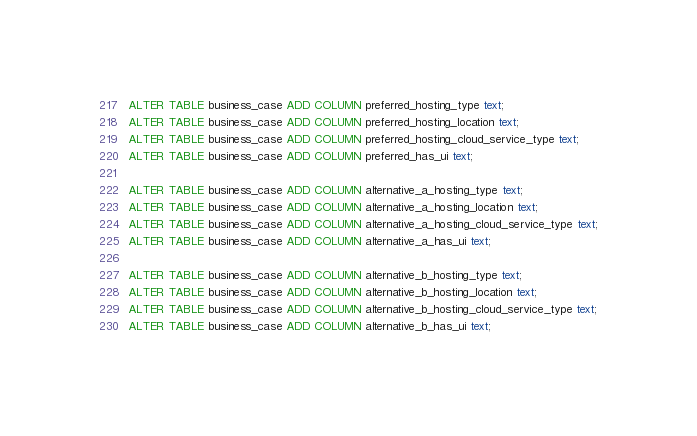Convert code to text. <code><loc_0><loc_0><loc_500><loc_500><_SQL_>ALTER TABLE business_case ADD COLUMN preferred_hosting_type text;
ALTER TABLE business_case ADD COLUMN preferred_hosting_location text;
ALTER TABLE business_case ADD COLUMN preferred_hosting_cloud_service_type text;
ALTER TABLE business_case ADD COLUMN preferred_has_ui text;

ALTER TABLE business_case ADD COLUMN alternative_a_hosting_type text;
ALTER TABLE business_case ADD COLUMN alternative_a_hosting_location text;
ALTER TABLE business_case ADD COLUMN alternative_a_hosting_cloud_service_type text;
ALTER TABLE business_case ADD COLUMN alternative_a_has_ui text;

ALTER TABLE business_case ADD COLUMN alternative_b_hosting_type text;
ALTER TABLE business_case ADD COLUMN alternative_b_hosting_location text;
ALTER TABLE business_case ADD COLUMN alternative_b_hosting_cloud_service_type text;
ALTER TABLE business_case ADD COLUMN alternative_b_has_ui text;
</code> 